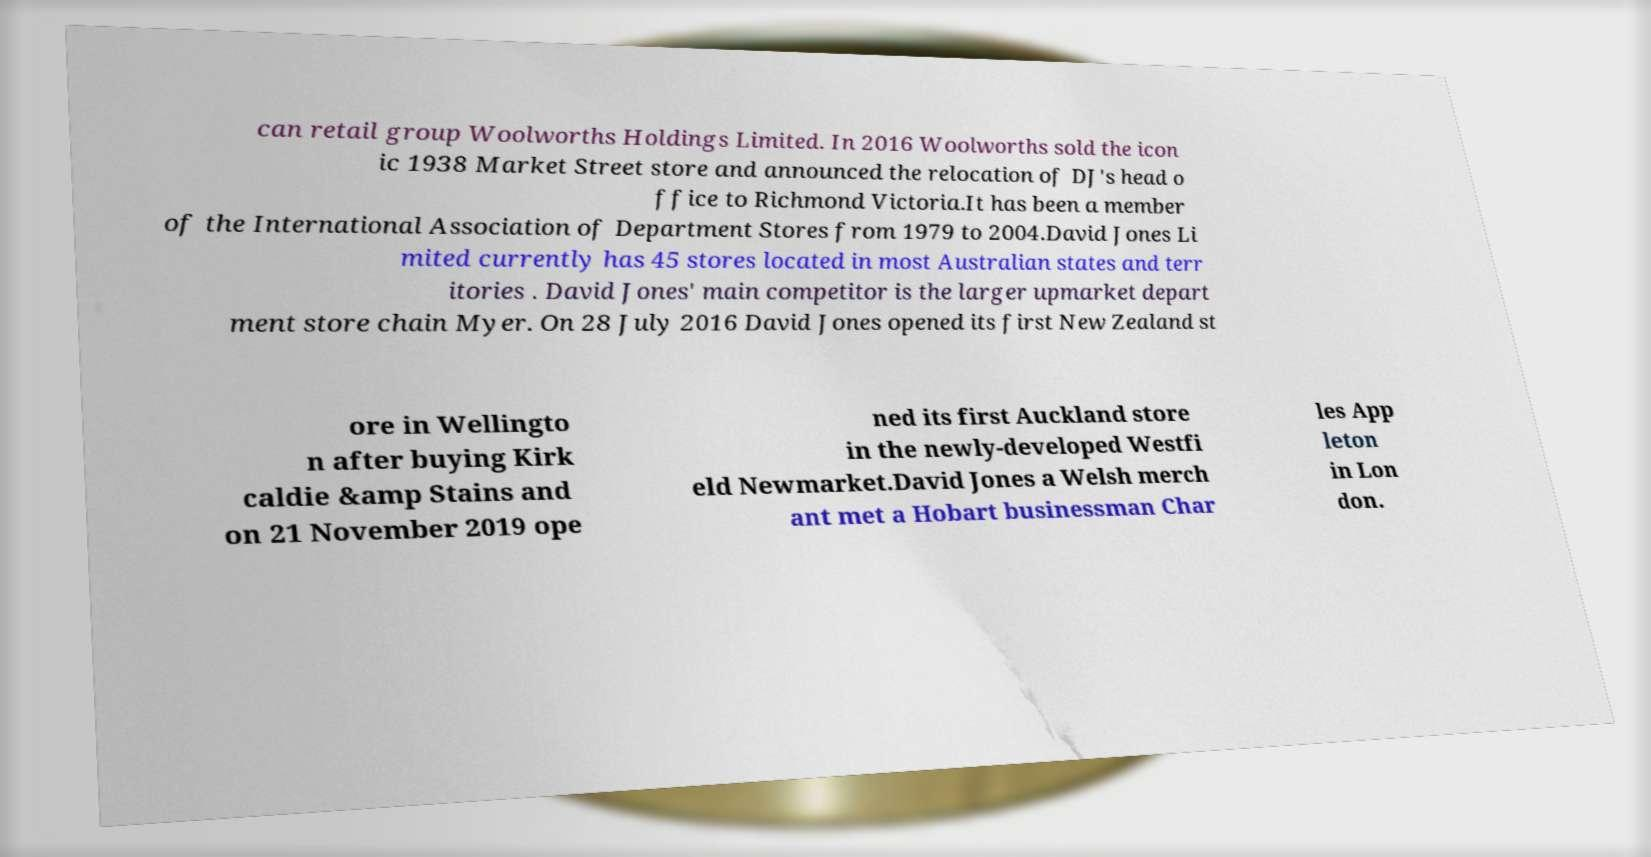What messages or text are displayed in this image? I need them in a readable, typed format. can retail group Woolworths Holdings Limited. In 2016 Woolworths sold the icon ic 1938 Market Street store and announced the relocation of DJ's head o ffice to Richmond Victoria.It has been a member of the International Association of Department Stores from 1979 to 2004.David Jones Li mited currently has 45 stores located in most Australian states and terr itories . David Jones' main competitor is the larger upmarket depart ment store chain Myer. On 28 July 2016 David Jones opened its first New Zealand st ore in Wellingto n after buying Kirk caldie &amp Stains and on 21 November 2019 ope ned its first Auckland store in the newly-developed Westfi eld Newmarket.David Jones a Welsh merch ant met a Hobart businessman Char les App leton in Lon don. 